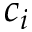<formula> <loc_0><loc_0><loc_500><loc_500>c _ { i }</formula> 